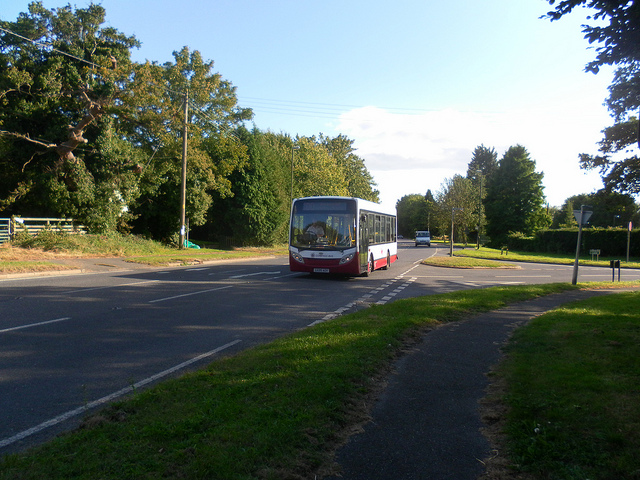<image>What landforms are in the background? I am not sure about the landforms in the background. It could be trees, hills, or even plain. What landforms are in the background? I don't know what landforms are in the background. Maybe it is trees, hills, or plain. 